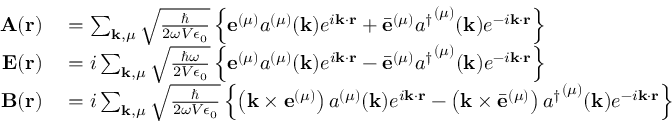Convert formula to latex. <formula><loc_0><loc_0><loc_500><loc_500>\begin{array} { r l } { A ( r ) } & = \sum _ { k , \mu } { \sqrt { \frac { } { 2 \omega V \epsilon _ { 0 } } } } \left \{ e ^ { ( \mu ) } a ^ { ( \mu ) } ( k ) e ^ { i k \cdot r } + { \bar { e } } ^ { ( \mu ) } { a ^ { \dagger } } ^ { ( \mu ) } ( k ) e ^ { - i k \cdot r } \right \} } \\ { E ( r ) } & = i \sum _ { k , \mu } { \sqrt { \frac { \hbar { \omega } } { 2 V \epsilon _ { 0 } } } } \left \{ e ^ { ( \mu ) } a ^ { ( \mu ) } ( k ) e ^ { i k \cdot r } - { \bar { e } } ^ { ( \mu ) } { a ^ { \dagger } } ^ { ( \mu ) } ( k ) e ^ { - i k \cdot r } \right \} } \\ { B ( r ) } & = i \sum _ { k , \mu } { \sqrt { \frac { } { 2 \omega V \epsilon _ { 0 } } } } \left \{ \left ( k \times e ^ { ( \mu ) } \right ) a ^ { ( \mu ) } ( k ) e ^ { i k \cdot r } - \left ( k \times { \bar { e } } ^ { ( \mu ) } \right ) { a ^ { \dagger } } ^ { ( \mu ) } ( k ) e ^ { - i k \cdot r } \right \} } \end{array}</formula> 